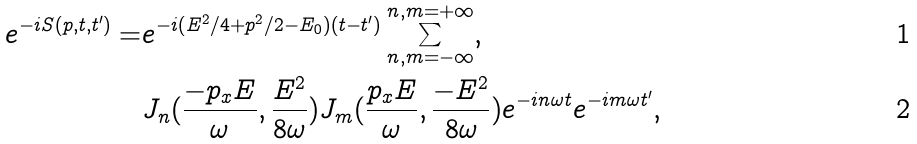Convert formula to latex. <formula><loc_0><loc_0><loc_500><loc_500>e ^ { - i S ( p , t , t ^ { \prime } ) } = & e ^ { - i ( E ^ { 2 } / 4 + p ^ { 2 } / 2 - E _ { 0 } ) ( t - t ^ { \prime } ) } \sum _ { n , m = - \infty } ^ { n , m = + \infty } , \\ & J _ { n } ( \frac { - p _ { x } E } { \omega } , \frac { E ^ { 2 } } { 8 { \omega } } ) J _ { m } ( \frac { p _ { x } E } { \omega } , \frac { - E ^ { 2 } } { 8 { \omega } } ) e ^ { - i n { \omega } t } e ^ { - i m { \omega } t ^ { \prime } } ,</formula> 